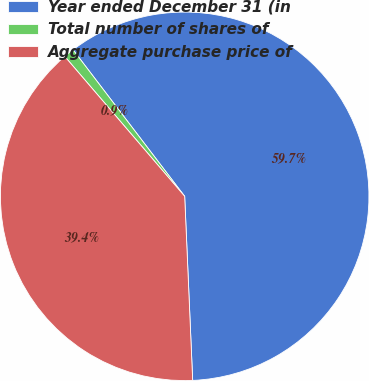Convert chart. <chart><loc_0><loc_0><loc_500><loc_500><pie_chart><fcel>Year ended December 31 (in<fcel>Total number of shares of<fcel>Aggregate purchase price of<nl><fcel>59.67%<fcel>0.92%<fcel>39.41%<nl></chart> 